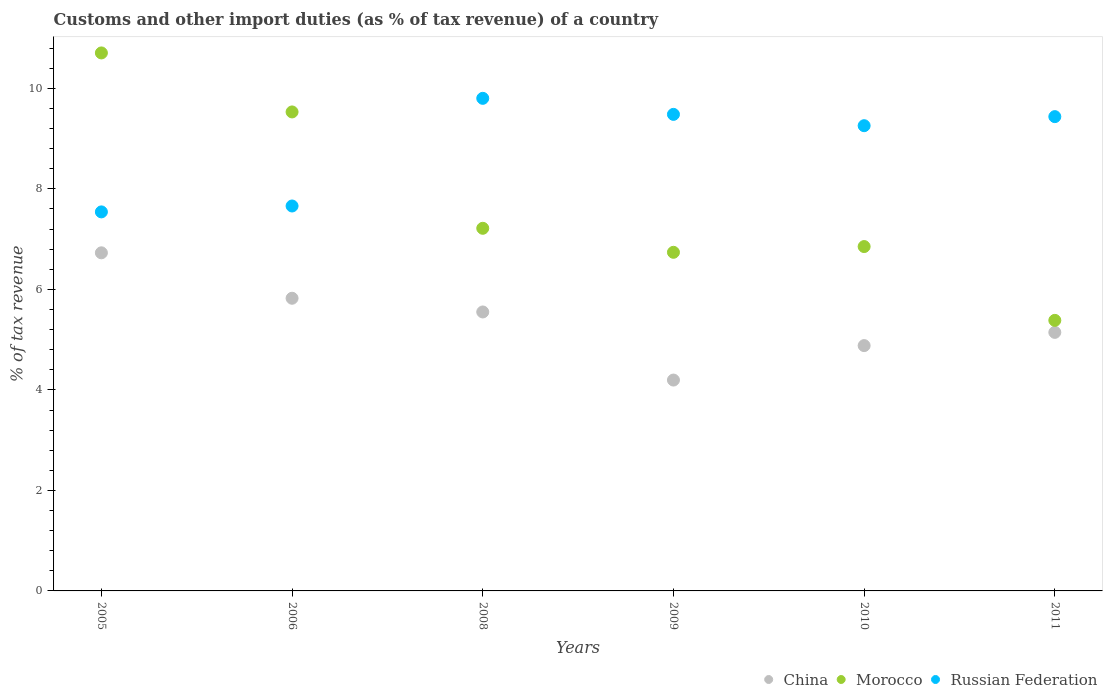What is the percentage of tax revenue from customs in China in 2011?
Give a very brief answer. 5.14. Across all years, what is the maximum percentage of tax revenue from customs in Morocco?
Your answer should be very brief. 10.71. Across all years, what is the minimum percentage of tax revenue from customs in Russian Federation?
Ensure brevity in your answer.  7.54. In which year was the percentage of tax revenue from customs in China minimum?
Your response must be concise. 2009. What is the total percentage of tax revenue from customs in Russian Federation in the graph?
Your response must be concise. 53.18. What is the difference between the percentage of tax revenue from customs in China in 2005 and that in 2011?
Your response must be concise. 1.58. What is the difference between the percentage of tax revenue from customs in Morocco in 2011 and the percentage of tax revenue from customs in Russian Federation in 2010?
Your answer should be very brief. -3.87. What is the average percentage of tax revenue from customs in Russian Federation per year?
Ensure brevity in your answer.  8.86. In the year 2011, what is the difference between the percentage of tax revenue from customs in Morocco and percentage of tax revenue from customs in China?
Provide a succinct answer. 0.24. In how many years, is the percentage of tax revenue from customs in China greater than 10.4 %?
Your answer should be very brief. 0. What is the ratio of the percentage of tax revenue from customs in China in 2008 to that in 2010?
Your response must be concise. 1.14. Is the percentage of tax revenue from customs in Russian Federation in 2010 less than that in 2011?
Keep it short and to the point. Yes. What is the difference between the highest and the second highest percentage of tax revenue from customs in Russian Federation?
Offer a very short reply. 0.32. What is the difference between the highest and the lowest percentage of tax revenue from customs in Russian Federation?
Provide a short and direct response. 2.26. How many dotlines are there?
Keep it short and to the point. 3. How many years are there in the graph?
Give a very brief answer. 6. What is the difference between two consecutive major ticks on the Y-axis?
Offer a terse response. 2. Are the values on the major ticks of Y-axis written in scientific E-notation?
Provide a short and direct response. No. Does the graph contain any zero values?
Offer a terse response. No. Does the graph contain grids?
Make the answer very short. No. How many legend labels are there?
Keep it short and to the point. 3. What is the title of the graph?
Your answer should be very brief. Customs and other import duties (as % of tax revenue) of a country. What is the label or title of the X-axis?
Make the answer very short. Years. What is the label or title of the Y-axis?
Your answer should be very brief. % of tax revenue. What is the % of tax revenue in China in 2005?
Give a very brief answer. 6.73. What is the % of tax revenue of Morocco in 2005?
Your answer should be very brief. 10.71. What is the % of tax revenue of Russian Federation in 2005?
Offer a very short reply. 7.54. What is the % of tax revenue in China in 2006?
Your answer should be very brief. 5.82. What is the % of tax revenue in Morocco in 2006?
Make the answer very short. 9.53. What is the % of tax revenue in Russian Federation in 2006?
Offer a terse response. 7.66. What is the % of tax revenue of China in 2008?
Provide a short and direct response. 5.55. What is the % of tax revenue in Morocco in 2008?
Your answer should be compact. 7.22. What is the % of tax revenue in Russian Federation in 2008?
Provide a short and direct response. 9.8. What is the % of tax revenue in China in 2009?
Offer a terse response. 4.2. What is the % of tax revenue in Morocco in 2009?
Give a very brief answer. 6.74. What is the % of tax revenue in Russian Federation in 2009?
Your answer should be very brief. 9.48. What is the % of tax revenue in China in 2010?
Provide a succinct answer. 4.88. What is the % of tax revenue of Morocco in 2010?
Provide a short and direct response. 6.85. What is the % of tax revenue in Russian Federation in 2010?
Give a very brief answer. 9.26. What is the % of tax revenue in China in 2011?
Provide a succinct answer. 5.14. What is the % of tax revenue in Morocco in 2011?
Make the answer very short. 5.38. What is the % of tax revenue in Russian Federation in 2011?
Provide a short and direct response. 9.44. Across all years, what is the maximum % of tax revenue of China?
Your answer should be compact. 6.73. Across all years, what is the maximum % of tax revenue in Morocco?
Offer a very short reply. 10.71. Across all years, what is the maximum % of tax revenue in Russian Federation?
Ensure brevity in your answer.  9.8. Across all years, what is the minimum % of tax revenue of China?
Provide a succinct answer. 4.2. Across all years, what is the minimum % of tax revenue of Morocco?
Ensure brevity in your answer.  5.38. Across all years, what is the minimum % of tax revenue of Russian Federation?
Give a very brief answer. 7.54. What is the total % of tax revenue of China in the graph?
Your answer should be very brief. 32.33. What is the total % of tax revenue in Morocco in the graph?
Ensure brevity in your answer.  46.43. What is the total % of tax revenue in Russian Federation in the graph?
Your answer should be compact. 53.18. What is the difference between the % of tax revenue in China in 2005 and that in 2006?
Provide a succinct answer. 0.9. What is the difference between the % of tax revenue in Morocco in 2005 and that in 2006?
Your answer should be compact. 1.17. What is the difference between the % of tax revenue in Russian Federation in 2005 and that in 2006?
Ensure brevity in your answer.  -0.12. What is the difference between the % of tax revenue of China in 2005 and that in 2008?
Provide a succinct answer. 1.18. What is the difference between the % of tax revenue in Morocco in 2005 and that in 2008?
Provide a short and direct response. 3.49. What is the difference between the % of tax revenue in Russian Federation in 2005 and that in 2008?
Give a very brief answer. -2.26. What is the difference between the % of tax revenue in China in 2005 and that in 2009?
Your answer should be very brief. 2.53. What is the difference between the % of tax revenue in Morocco in 2005 and that in 2009?
Provide a succinct answer. 3.97. What is the difference between the % of tax revenue in Russian Federation in 2005 and that in 2009?
Your response must be concise. -1.94. What is the difference between the % of tax revenue of China in 2005 and that in 2010?
Provide a short and direct response. 1.85. What is the difference between the % of tax revenue in Morocco in 2005 and that in 2010?
Ensure brevity in your answer.  3.85. What is the difference between the % of tax revenue in Russian Federation in 2005 and that in 2010?
Make the answer very short. -1.72. What is the difference between the % of tax revenue in China in 2005 and that in 2011?
Provide a succinct answer. 1.58. What is the difference between the % of tax revenue of Morocco in 2005 and that in 2011?
Your answer should be very brief. 5.32. What is the difference between the % of tax revenue of Russian Federation in 2005 and that in 2011?
Offer a terse response. -1.9. What is the difference between the % of tax revenue in China in 2006 and that in 2008?
Ensure brevity in your answer.  0.27. What is the difference between the % of tax revenue of Morocco in 2006 and that in 2008?
Offer a terse response. 2.32. What is the difference between the % of tax revenue of Russian Federation in 2006 and that in 2008?
Your answer should be compact. -2.14. What is the difference between the % of tax revenue of China in 2006 and that in 2009?
Keep it short and to the point. 1.63. What is the difference between the % of tax revenue of Morocco in 2006 and that in 2009?
Your answer should be compact. 2.79. What is the difference between the % of tax revenue in Russian Federation in 2006 and that in 2009?
Offer a terse response. -1.82. What is the difference between the % of tax revenue in China in 2006 and that in 2010?
Make the answer very short. 0.94. What is the difference between the % of tax revenue in Morocco in 2006 and that in 2010?
Make the answer very short. 2.68. What is the difference between the % of tax revenue in Russian Federation in 2006 and that in 2010?
Provide a succinct answer. -1.6. What is the difference between the % of tax revenue of China in 2006 and that in 2011?
Your response must be concise. 0.68. What is the difference between the % of tax revenue in Morocco in 2006 and that in 2011?
Provide a short and direct response. 4.15. What is the difference between the % of tax revenue in Russian Federation in 2006 and that in 2011?
Offer a very short reply. -1.78. What is the difference between the % of tax revenue in China in 2008 and that in 2009?
Your response must be concise. 1.36. What is the difference between the % of tax revenue in Morocco in 2008 and that in 2009?
Make the answer very short. 0.48. What is the difference between the % of tax revenue in Russian Federation in 2008 and that in 2009?
Make the answer very short. 0.32. What is the difference between the % of tax revenue of China in 2008 and that in 2010?
Your answer should be compact. 0.67. What is the difference between the % of tax revenue in Morocco in 2008 and that in 2010?
Keep it short and to the point. 0.36. What is the difference between the % of tax revenue of Russian Federation in 2008 and that in 2010?
Your answer should be compact. 0.54. What is the difference between the % of tax revenue of China in 2008 and that in 2011?
Offer a very short reply. 0.41. What is the difference between the % of tax revenue of Morocco in 2008 and that in 2011?
Your answer should be compact. 1.83. What is the difference between the % of tax revenue in Russian Federation in 2008 and that in 2011?
Your answer should be compact. 0.36. What is the difference between the % of tax revenue of China in 2009 and that in 2010?
Keep it short and to the point. -0.69. What is the difference between the % of tax revenue in Morocco in 2009 and that in 2010?
Your response must be concise. -0.11. What is the difference between the % of tax revenue of Russian Federation in 2009 and that in 2010?
Provide a succinct answer. 0.23. What is the difference between the % of tax revenue in China in 2009 and that in 2011?
Provide a succinct answer. -0.95. What is the difference between the % of tax revenue in Morocco in 2009 and that in 2011?
Ensure brevity in your answer.  1.35. What is the difference between the % of tax revenue of Russian Federation in 2009 and that in 2011?
Your answer should be very brief. 0.04. What is the difference between the % of tax revenue of China in 2010 and that in 2011?
Keep it short and to the point. -0.26. What is the difference between the % of tax revenue of Morocco in 2010 and that in 2011?
Ensure brevity in your answer.  1.47. What is the difference between the % of tax revenue in Russian Federation in 2010 and that in 2011?
Make the answer very short. -0.18. What is the difference between the % of tax revenue in China in 2005 and the % of tax revenue in Morocco in 2006?
Offer a terse response. -2.8. What is the difference between the % of tax revenue of China in 2005 and the % of tax revenue of Russian Federation in 2006?
Ensure brevity in your answer.  -0.93. What is the difference between the % of tax revenue in Morocco in 2005 and the % of tax revenue in Russian Federation in 2006?
Make the answer very short. 3.05. What is the difference between the % of tax revenue of China in 2005 and the % of tax revenue of Morocco in 2008?
Provide a succinct answer. -0.49. What is the difference between the % of tax revenue in China in 2005 and the % of tax revenue in Russian Federation in 2008?
Your answer should be compact. -3.07. What is the difference between the % of tax revenue of Morocco in 2005 and the % of tax revenue of Russian Federation in 2008?
Your answer should be very brief. 0.9. What is the difference between the % of tax revenue of China in 2005 and the % of tax revenue of Morocco in 2009?
Keep it short and to the point. -0.01. What is the difference between the % of tax revenue in China in 2005 and the % of tax revenue in Russian Federation in 2009?
Provide a short and direct response. -2.75. What is the difference between the % of tax revenue in Morocco in 2005 and the % of tax revenue in Russian Federation in 2009?
Keep it short and to the point. 1.22. What is the difference between the % of tax revenue in China in 2005 and the % of tax revenue in Morocco in 2010?
Provide a short and direct response. -0.12. What is the difference between the % of tax revenue of China in 2005 and the % of tax revenue of Russian Federation in 2010?
Offer a very short reply. -2.53. What is the difference between the % of tax revenue in Morocco in 2005 and the % of tax revenue in Russian Federation in 2010?
Provide a succinct answer. 1.45. What is the difference between the % of tax revenue of China in 2005 and the % of tax revenue of Morocco in 2011?
Keep it short and to the point. 1.34. What is the difference between the % of tax revenue of China in 2005 and the % of tax revenue of Russian Federation in 2011?
Give a very brief answer. -2.71. What is the difference between the % of tax revenue in Morocco in 2005 and the % of tax revenue in Russian Federation in 2011?
Offer a very short reply. 1.27. What is the difference between the % of tax revenue of China in 2006 and the % of tax revenue of Morocco in 2008?
Give a very brief answer. -1.39. What is the difference between the % of tax revenue of China in 2006 and the % of tax revenue of Russian Federation in 2008?
Ensure brevity in your answer.  -3.98. What is the difference between the % of tax revenue of Morocco in 2006 and the % of tax revenue of Russian Federation in 2008?
Offer a very short reply. -0.27. What is the difference between the % of tax revenue in China in 2006 and the % of tax revenue in Morocco in 2009?
Your response must be concise. -0.91. What is the difference between the % of tax revenue of China in 2006 and the % of tax revenue of Russian Federation in 2009?
Offer a very short reply. -3.66. What is the difference between the % of tax revenue of Morocco in 2006 and the % of tax revenue of Russian Federation in 2009?
Provide a short and direct response. 0.05. What is the difference between the % of tax revenue of China in 2006 and the % of tax revenue of Morocco in 2010?
Offer a very short reply. -1.03. What is the difference between the % of tax revenue of China in 2006 and the % of tax revenue of Russian Federation in 2010?
Keep it short and to the point. -3.43. What is the difference between the % of tax revenue of Morocco in 2006 and the % of tax revenue of Russian Federation in 2010?
Provide a succinct answer. 0.27. What is the difference between the % of tax revenue in China in 2006 and the % of tax revenue in Morocco in 2011?
Offer a terse response. 0.44. What is the difference between the % of tax revenue of China in 2006 and the % of tax revenue of Russian Federation in 2011?
Your answer should be very brief. -3.61. What is the difference between the % of tax revenue in Morocco in 2006 and the % of tax revenue in Russian Federation in 2011?
Provide a short and direct response. 0.09. What is the difference between the % of tax revenue of China in 2008 and the % of tax revenue of Morocco in 2009?
Keep it short and to the point. -1.19. What is the difference between the % of tax revenue of China in 2008 and the % of tax revenue of Russian Federation in 2009?
Your answer should be compact. -3.93. What is the difference between the % of tax revenue in Morocco in 2008 and the % of tax revenue in Russian Federation in 2009?
Keep it short and to the point. -2.27. What is the difference between the % of tax revenue of China in 2008 and the % of tax revenue of Morocco in 2010?
Make the answer very short. -1.3. What is the difference between the % of tax revenue of China in 2008 and the % of tax revenue of Russian Federation in 2010?
Keep it short and to the point. -3.71. What is the difference between the % of tax revenue in Morocco in 2008 and the % of tax revenue in Russian Federation in 2010?
Ensure brevity in your answer.  -2.04. What is the difference between the % of tax revenue of China in 2008 and the % of tax revenue of Morocco in 2011?
Provide a succinct answer. 0.17. What is the difference between the % of tax revenue of China in 2008 and the % of tax revenue of Russian Federation in 2011?
Provide a short and direct response. -3.89. What is the difference between the % of tax revenue in Morocco in 2008 and the % of tax revenue in Russian Federation in 2011?
Offer a very short reply. -2.22. What is the difference between the % of tax revenue of China in 2009 and the % of tax revenue of Morocco in 2010?
Provide a succinct answer. -2.66. What is the difference between the % of tax revenue of China in 2009 and the % of tax revenue of Russian Federation in 2010?
Your response must be concise. -5.06. What is the difference between the % of tax revenue of Morocco in 2009 and the % of tax revenue of Russian Federation in 2010?
Provide a succinct answer. -2.52. What is the difference between the % of tax revenue of China in 2009 and the % of tax revenue of Morocco in 2011?
Your response must be concise. -1.19. What is the difference between the % of tax revenue of China in 2009 and the % of tax revenue of Russian Federation in 2011?
Your answer should be very brief. -5.24. What is the difference between the % of tax revenue of Morocco in 2009 and the % of tax revenue of Russian Federation in 2011?
Your answer should be compact. -2.7. What is the difference between the % of tax revenue of China in 2010 and the % of tax revenue of Morocco in 2011?
Offer a very short reply. -0.5. What is the difference between the % of tax revenue in China in 2010 and the % of tax revenue in Russian Federation in 2011?
Your response must be concise. -4.56. What is the difference between the % of tax revenue in Morocco in 2010 and the % of tax revenue in Russian Federation in 2011?
Your response must be concise. -2.59. What is the average % of tax revenue in China per year?
Provide a short and direct response. 5.39. What is the average % of tax revenue in Morocco per year?
Your answer should be very brief. 7.74. What is the average % of tax revenue in Russian Federation per year?
Provide a short and direct response. 8.86. In the year 2005, what is the difference between the % of tax revenue of China and % of tax revenue of Morocco?
Provide a short and direct response. -3.98. In the year 2005, what is the difference between the % of tax revenue in China and % of tax revenue in Russian Federation?
Provide a short and direct response. -0.81. In the year 2005, what is the difference between the % of tax revenue in Morocco and % of tax revenue in Russian Federation?
Offer a terse response. 3.16. In the year 2006, what is the difference between the % of tax revenue in China and % of tax revenue in Morocco?
Offer a very short reply. -3.71. In the year 2006, what is the difference between the % of tax revenue of China and % of tax revenue of Russian Federation?
Your response must be concise. -1.84. In the year 2006, what is the difference between the % of tax revenue in Morocco and % of tax revenue in Russian Federation?
Offer a terse response. 1.87. In the year 2008, what is the difference between the % of tax revenue of China and % of tax revenue of Morocco?
Your answer should be very brief. -1.66. In the year 2008, what is the difference between the % of tax revenue in China and % of tax revenue in Russian Federation?
Provide a short and direct response. -4.25. In the year 2008, what is the difference between the % of tax revenue of Morocco and % of tax revenue of Russian Federation?
Ensure brevity in your answer.  -2.59. In the year 2009, what is the difference between the % of tax revenue in China and % of tax revenue in Morocco?
Provide a short and direct response. -2.54. In the year 2009, what is the difference between the % of tax revenue in China and % of tax revenue in Russian Federation?
Offer a terse response. -5.29. In the year 2009, what is the difference between the % of tax revenue of Morocco and % of tax revenue of Russian Federation?
Provide a succinct answer. -2.74. In the year 2010, what is the difference between the % of tax revenue in China and % of tax revenue in Morocco?
Provide a succinct answer. -1.97. In the year 2010, what is the difference between the % of tax revenue in China and % of tax revenue in Russian Federation?
Your answer should be compact. -4.38. In the year 2010, what is the difference between the % of tax revenue of Morocco and % of tax revenue of Russian Federation?
Your answer should be very brief. -2.41. In the year 2011, what is the difference between the % of tax revenue in China and % of tax revenue in Morocco?
Offer a terse response. -0.24. In the year 2011, what is the difference between the % of tax revenue in China and % of tax revenue in Russian Federation?
Your response must be concise. -4.29. In the year 2011, what is the difference between the % of tax revenue in Morocco and % of tax revenue in Russian Federation?
Provide a succinct answer. -4.05. What is the ratio of the % of tax revenue of China in 2005 to that in 2006?
Your response must be concise. 1.16. What is the ratio of the % of tax revenue of Morocco in 2005 to that in 2006?
Keep it short and to the point. 1.12. What is the ratio of the % of tax revenue of Russian Federation in 2005 to that in 2006?
Ensure brevity in your answer.  0.98. What is the ratio of the % of tax revenue in China in 2005 to that in 2008?
Offer a terse response. 1.21. What is the ratio of the % of tax revenue of Morocco in 2005 to that in 2008?
Make the answer very short. 1.48. What is the ratio of the % of tax revenue of Russian Federation in 2005 to that in 2008?
Keep it short and to the point. 0.77. What is the ratio of the % of tax revenue in China in 2005 to that in 2009?
Your answer should be very brief. 1.6. What is the ratio of the % of tax revenue of Morocco in 2005 to that in 2009?
Offer a terse response. 1.59. What is the ratio of the % of tax revenue in Russian Federation in 2005 to that in 2009?
Your answer should be very brief. 0.8. What is the ratio of the % of tax revenue in China in 2005 to that in 2010?
Your response must be concise. 1.38. What is the ratio of the % of tax revenue of Morocco in 2005 to that in 2010?
Offer a terse response. 1.56. What is the ratio of the % of tax revenue in Russian Federation in 2005 to that in 2010?
Offer a terse response. 0.81. What is the ratio of the % of tax revenue in China in 2005 to that in 2011?
Your response must be concise. 1.31. What is the ratio of the % of tax revenue in Morocco in 2005 to that in 2011?
Give a very brief answer. 1.99. What is the ratio of the % of tax revenue of Russian Federation in 2005 to that in 2011?
Provide a succinct answer. 0.8. What is the ratio of the % of tax revenue of China in 2006 to that in 2008?
Keep it short and to the point. 1.05. What is the ratio of the % of tax revenue of Morocco in 2006 to that in 2008?
Your answer should be very brief. 1.32. What is the ratio of the % of tax revenue in Russian Federation in 2006 to that in 2008?
Offer a very short reply. 0.78. What is the ratio of the % of tax revenue in China in 2006 to that in 2009?
Provide a short and direct response. 1.39. What is the ratio of the % of tax revenue in Morocco in 2006 to that in 2009?
Provide a succinct answer. 1.41. What is the ratio of the % of tax revenue of Russian Federation in 2006 to that in 2009?
Provide a succinct answer. 0.81. What is the ratio of the % of tax revenue in China in 2006 to that in 2010?
Offer a very short reply. 1.19. What is the ratio of the % of tax revenue in Morocco in 2006 to that in 2010?
Your answer should be compact. 1.39. What is the ratio of the % of tax revenue of Russian Federation in 2006 to that in 2010?
Keep it short and to the point. 0.83. What is the ratio of the % of tax revenue of China in 2006 to that in 2011?
Give a very brief answer. 1.13. What is the ratio of the % of tax revenue in Morocco in 2006 to that in 2011?
Make the answer very short. 1.77. What is the ratio of the % of tax revenue of Russian Federation in 2006 to that in 2011?
Your answer should be compact. 0.81. What is the ratio of the % of tax revenue of China in 2008 to that in 2009?
Keep it short and to the point. 1.32. What is the ratio of the % of tax revenue of Morocco in 2008 to that in 2009?
Keep it short and to the point. 1.07. What is the ratio of the % of tax revenue of Russian Federation in 2008 to that in 2009?
Your answer should be compact. 1.03. What is the ratio of the % of tax revenue of China in 2008 to that in 2010?
Give a very brief answer. 1.14. What is the ratio of the % of tax revenue of Morocco in 2008 to that in 2010?
Your answer should be compact. 1.05. What is the ratio of the % of tax revenue in Russian Federation in 2008 to that in 2010?
Your answer should be compact. 1.06. What is the ratio of the % of tax revenue in China in 2008 to that in 2011?
Your answer should be compact. 1.08. What is the ratio of the % of tax revenue in Morocco in 2008 to that in 2011?
Provide a succinct answer. 1.34. What is the ratio of the % of tax revenue in Russian Federation in 2008 to that in 2011?
Provide a succinct answer. 1.04. What is the ratio of the % of tax revenue of China in 2009 to that in 2010?
Ensure brevity in your answer.  0.86. What is the ratio of the % of tax revenue of Morocco in 2009 to that in 2010?
Keep it short and to the point. 0.98. What is the ratio of the % of tax revenue in Russian Federation in 2009 to that in 2010?
Provide a short and direct response. 1.02. What is the ratio of the % of tax revenue of China in 2009 to that in 2011?
Offer a terse response. 0.82. What is the ratio of the % of tax revenue in Morocco in 2009 to that in 2011?
Your answer should be compact. 1.25. What is the ratio of the % of tax revenue of China in 2010 to that in 2011?
Your answer should be compact. 0.95. What is the ratio of the % of tax revenue of Morocco in 2010 to that in 2011?
Give a very brief answer. 1.27. What is the ratio of the % of tax revenue of Russian Federation in 2010 to that in 2011?
Make the answer very short. 0.98. What is the difference between the highest and the second highest % of tax revenue of China?
Offer a terse response. 0.9. What is the difference between the highest and the second highest % of tax revenue of Morocco?
Your answer should be compact. 1.17. What is the difference between the highest and the second highest % of tax revenue in Russian Federation?
Give a very brief answer. 0.32. What is the difference between the highest and the lowest % of tax revenue of China?
Provide a short and direct response. 2.53. What is the difference between the highest and the lowest % of tax revenue in Morocco?
Provide a succinct answer. 5.32. What is the difference between the highest and the lowest % of tax revenue of Russian Federation?
Offer a terse response. 2.26. 